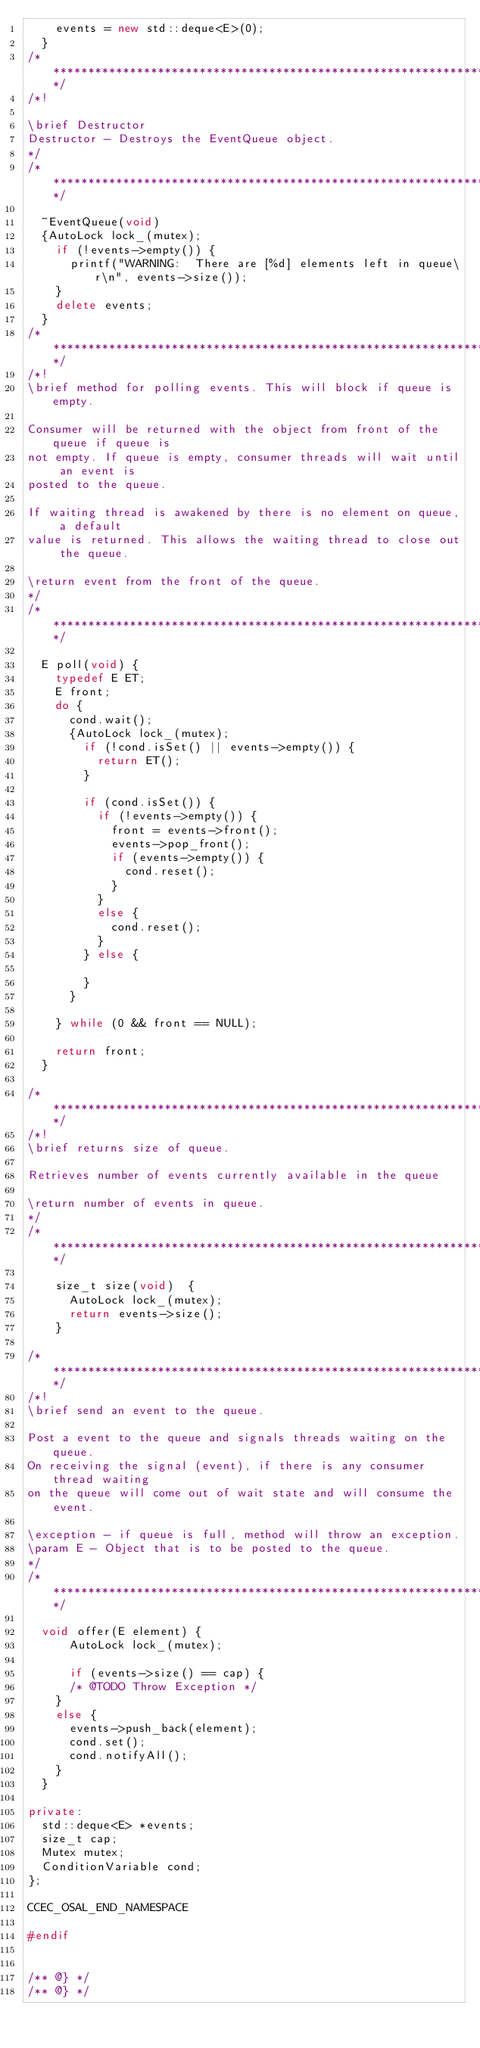Convert code to text. <code><loc_0><loc_0><loc_500><loc_500><_C++_>		events = new std::deque<E>(0);
	}
/***************************************************************************/
/*!

\brief Destructor
Destructor - Destroys the EventQueue object.
*/
/**************************************************************************/

	~EventQueue(void)
	{AutoLock lock_(mutex);
		if (!events->empty()) {
			printf("WARNING:  There are [%d] elements left in queue\r\n", events->size());
		}
		delete events;
	}
/***************************************************************************/
/*!
\brief method for polling events. This will block if queue is empty.

Consumer will be returned with the object from front of the queue if queue is
not empty. If queue is empty, consumer threads will wait until an event is 
posted to the queue.

If waiting thread is awakened by there is no element on queue, a default
value is returned. This allows the waiting thread to close out the queue.

\return event from the front of the queue.
*/
/**************************************************************************/

	E poll(void) {
		typedef E ET;
		E front;
		do {
			cond.wait();
			{AutoLock lock_(mutex);
				if (!cond.isSet() || events->empty()) {
					return ET();
				}

				if (cond.isSet()) {
					if (!events->empty()) {
						front = events->front();
						events->pop_front();
						if (events->empty()) {
							cond.reset();
						}
					}
					else {
						cond.reset();
					}
				} else {

				}
			}

		} while (0 && front == NULL);

		return front;
	}
	
/***************************************************************************/
/*!
\brief returns size of queue.

Retrieves number of events currently available in the queue

\return number of events in queue.
*/
/**************************************************************************/

    size_t size(void)  {
    	AutoLock lock_(mutex);
    	return events->size();
    }
	
/***************************************************************************/
/*!
\brief send an event to the queue.

Post a event to the queue and signals threads waiting on the queue.
On receiving the signal (event), if there is any consumer thread waiting
on the queue will come out of wait state and will consume the event.

\exception - if queue is full, method will throw an exception.
\param E - Object that is to be posted to the queue.
*/
/**************************************************************************/

	void offer(E element) {
    	AutoLock lock_(mutex);

    	if (events->size() == cap) {
			/* @TODO Throw Exception */
		}
		else {
			events->push_back(element);
			cond.set();
			cond.notifyAll();
		}
	}

private:
	std::deque<E> *events;
	size_t cap;
	Mutex mutex;
	ConditionVariable cond;
};

CCEC_OSAL_END_NAMESPACE

#endif


/** @} */
/** @} */
</code> 